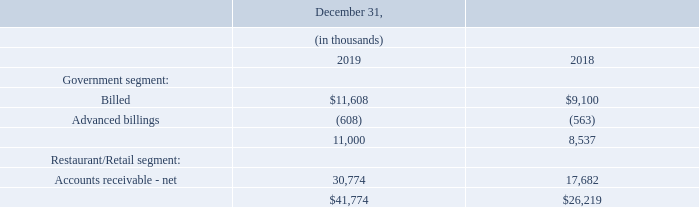Note 6 — Accounts Receivable, net
The Company’s net accounts receivable consists of:
At December 31, 2019 and 2018, the Company had recorded allowances for doubtful accounts of $1.8 million and $1.3 million, respectively, against Restaurant/Retail segment accounts receivable. Write-offs of accounts receivable during fiscal years 2019 and 2018 were $0.3 million and $0.4 million, respectively. The bad debt expense which is recorded in the consolidated statements of operations was $0.8 million and $0.8 million in 2019 and 2018, respectively.
Receivables recorded as of December 31, 2019 and 2018 all represent unconditional rights to payments from customers.
How much allowances for doubtful accounts was recorded against Restaurant/Retail segment accounts receivable at December 31, 2019 and 2018 respectively? $1.8 million, $1.3 million. How much was the Write-offs of accounts receivable during fiscal years 2019 and 2018 respectively? $0.3 million, $0.4 million. How much bad debt expense was recorded in 2019 and 2018 respectively? $0.8 million, $0.8 million. What is the change in Government segment: Billed between December 31, 2018 and 2019?
Answer scale should be: thousand. 11,608-9,100
Answer: 2508. What is the change in Government segment: Advanced billings between December 31, 2018 and 2019?
Answer scale should be: thousand. 608-563
Answer: 45. What is the average Government segment: Billed for December 31, 2018 and 2019?
Answer scale should be: thousand. (11,608+9,100) / 2
Answer: 10354. 